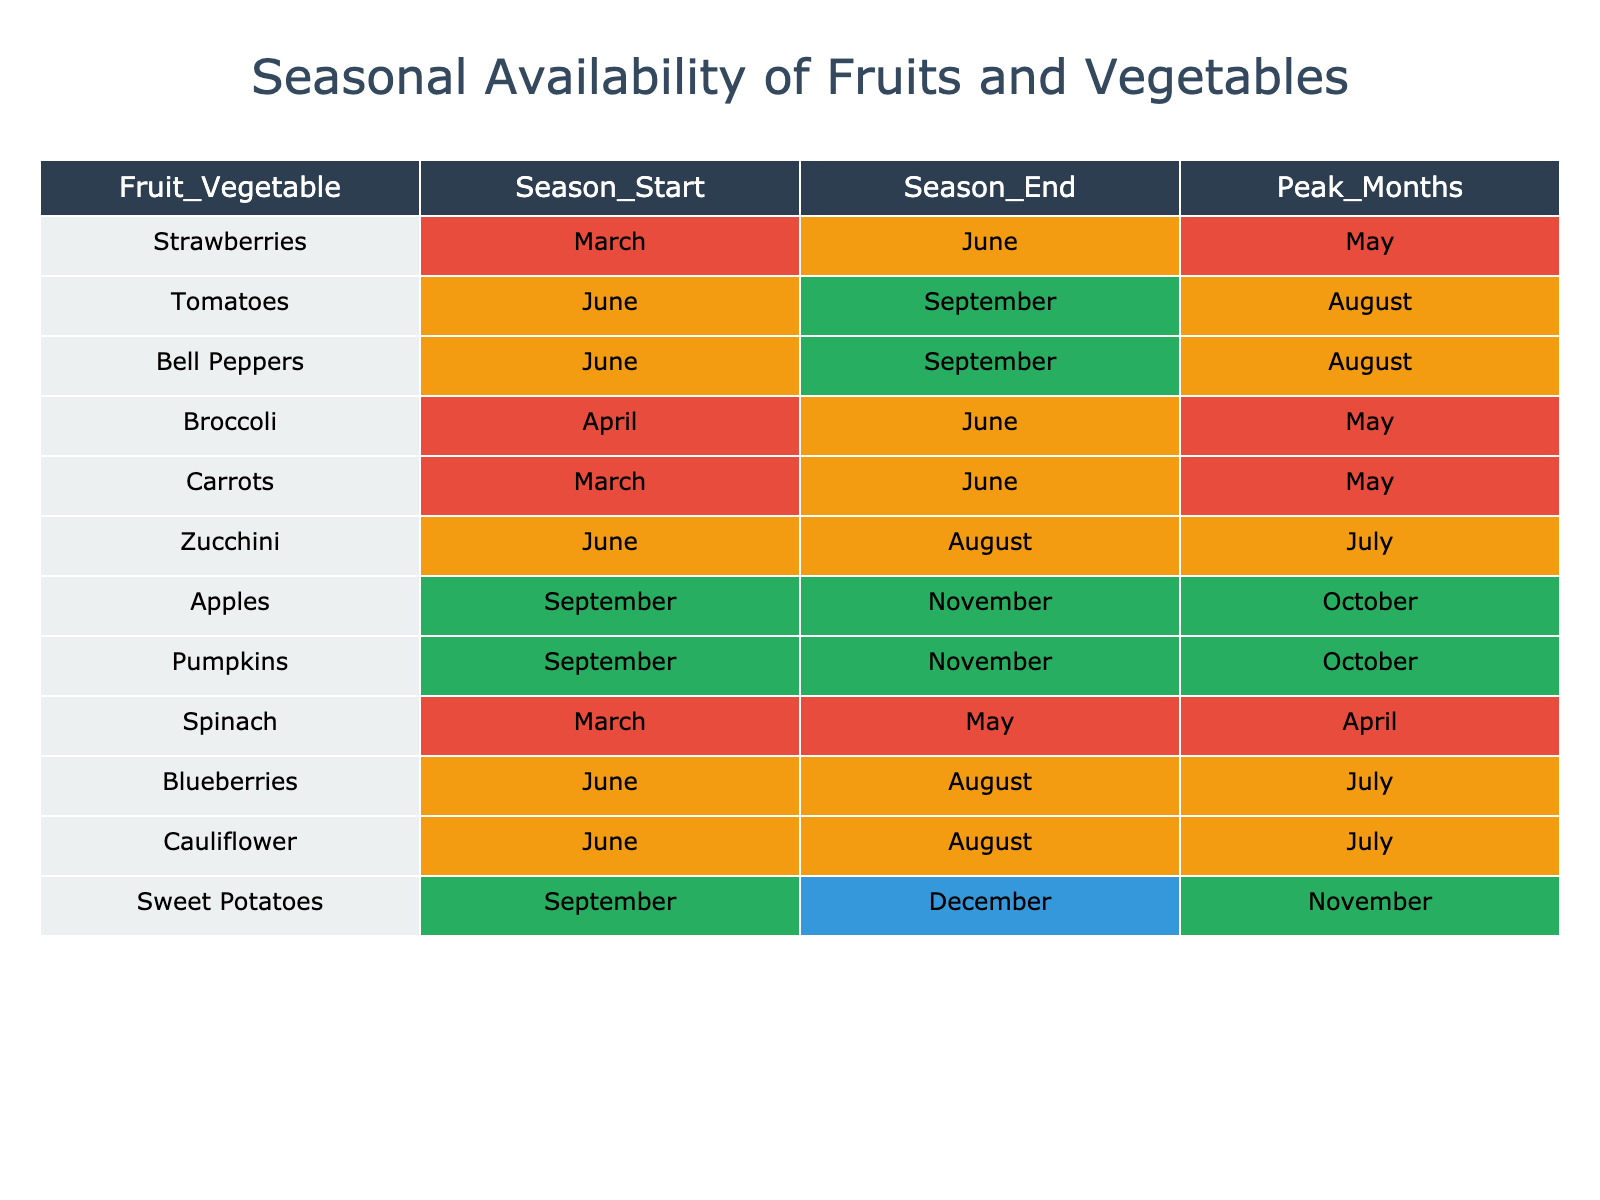What are the peak months for strawberries? The table indicates that strawberries have their peak months listed under the 'Peak_Months' column. Referring to the row for strawberries, we see that the peak months are marked as May.
Answer: May Which vegetables are available during the months of June through August? To answer this, we must look at the 'Season_Start' and 'Season_End' columns. Specifically, we need to identify vegetables that have a start month of June or earlier and an end month of August or later. By checking the table, we find that both zucchini and bell peppers fall within this range.
Answer: Zucchini, Bell Peppers Is broccoli available in the month of May? Checking the table, we find that broccoli's 'Season_Start' is in April and its 'Season_End' is in June. Since May is between these months, broccoli is indeed available during this time.
Answer: Yes How many fruits or vegetables peak in the month of October? We look at the 'Peak_Months' column to find any entries that list October. In the table, both apples and pumpkins peak in October. Thus, there are two entries that meet this criteria.
Answer: 2 What is the duration of the growing season for carrots? To find the duration, we look at the 'Season_Start' and 'Season_End' columns for carrots. Carrots start in March and end in June. The duration can be calculated by counting the number of months from March to June, resulting in a total of four months.
Answer: 4 months Are there any fruits that are available throughout the months of September to November? We need to check the 'Season_Start' and 'Season_End' columns for fruits that begin in September or earlier and end in November or later. According to the table, sweet potatoes, apples, and pumpkins are available during this timeframe, confirming that there are indeed fruits available.
Answer: Yes Which vegetable has the longest peak month duration and what is that duration? We must look at the 'Peak_Months' column for each vegetable and identify the one with the longest peak period. For instance, zucchini and blueberries peak for two months, while sweet potatoes peak for one month. By reviewing the data, we can conclude that the maximum peak duration is two months for zucchini and blueberries.
Answer: 2 months Is spinach available all summer long? Checking the 'Season_Start' and 'Season_End' columns for spinach, we find it starts in March and ends in May, which does not cover the summer months (June, July, August). Therefore, spinach is not available all summer long.
Answer: No 